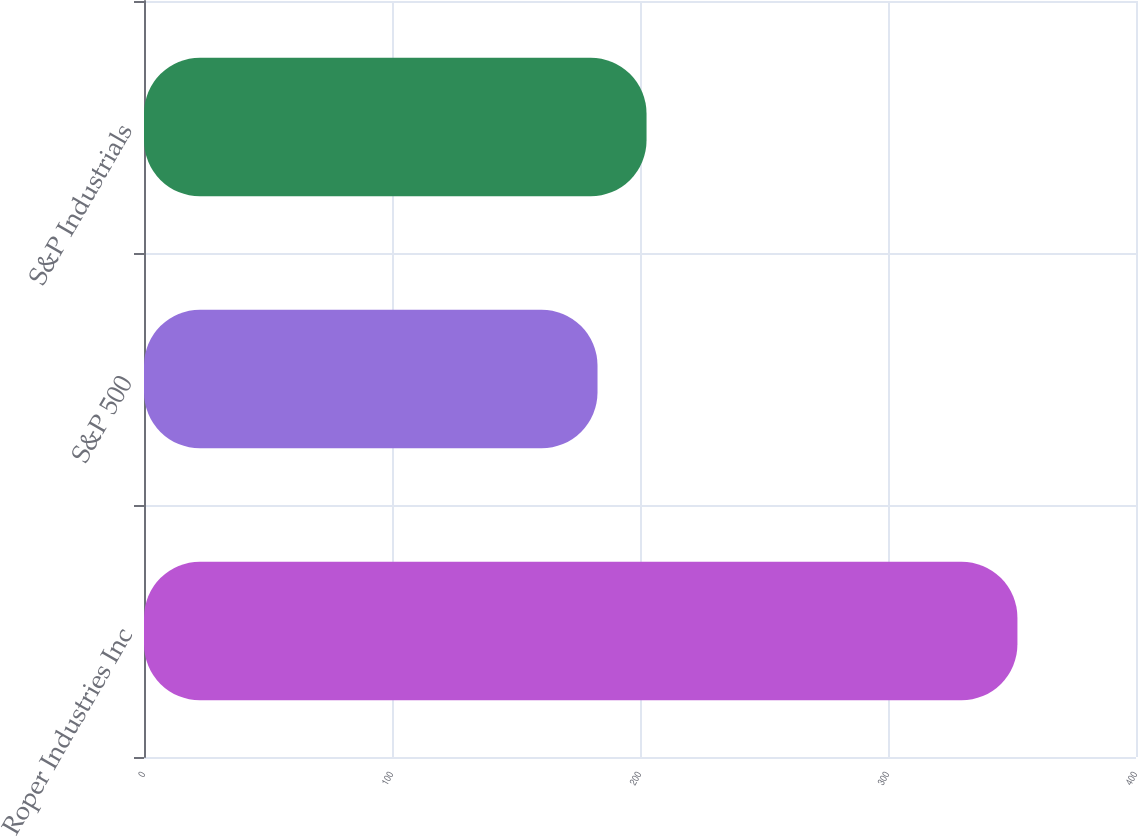Convert chart to OTSL. <chart><loc_0><loc_0><loc_500><loc_500><bar_chart><fcel>Roper Industries Inc<fcel>S&P 500<fcel>S&P Industrials<nl><fcel>352.19<fcel>182.87<fcel>202.64<nl></chart> 